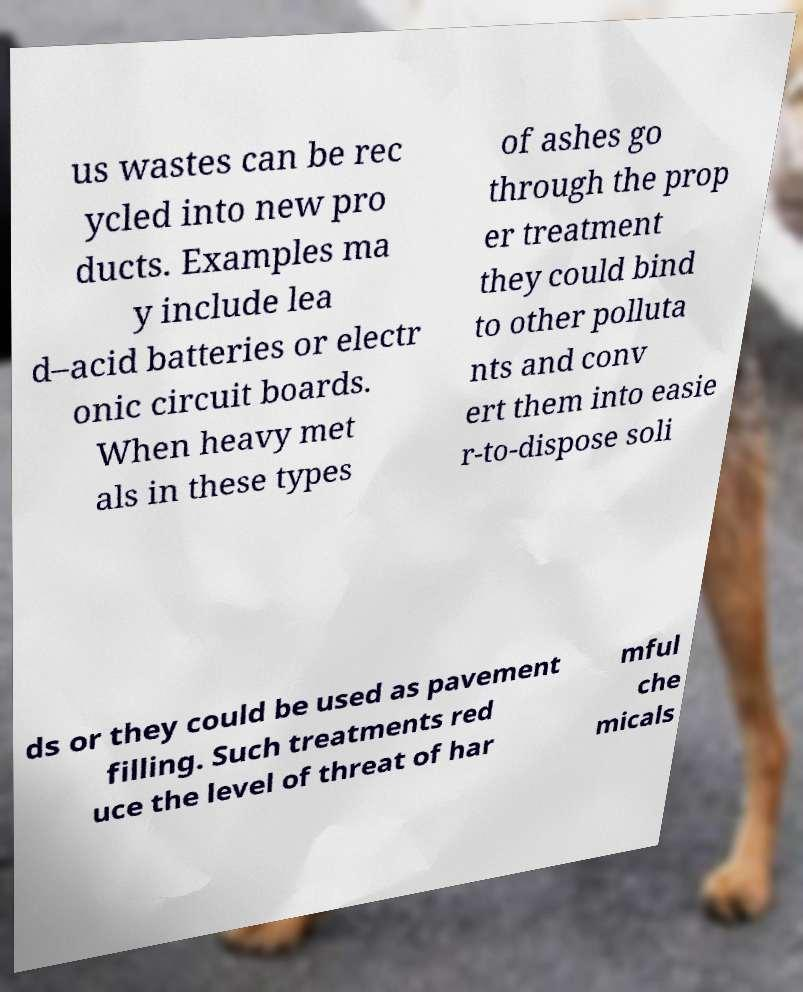Can you read and provide the text displayed in the image?This photo seems to have some interesting text. Can you extract and type it out for me? us wastes can be rec ycled into new pro ducts. Examples ma y include lea d–acid batteries or electr onic circuit boards. When heavy met als in these types of ashes go through the prop er treatment they could bind to other polluta nts and conv ert them into easie r-to-dispose soli ds or they could be used as pavement filling. Such treatments red uce the level of threat of har mful che micals 